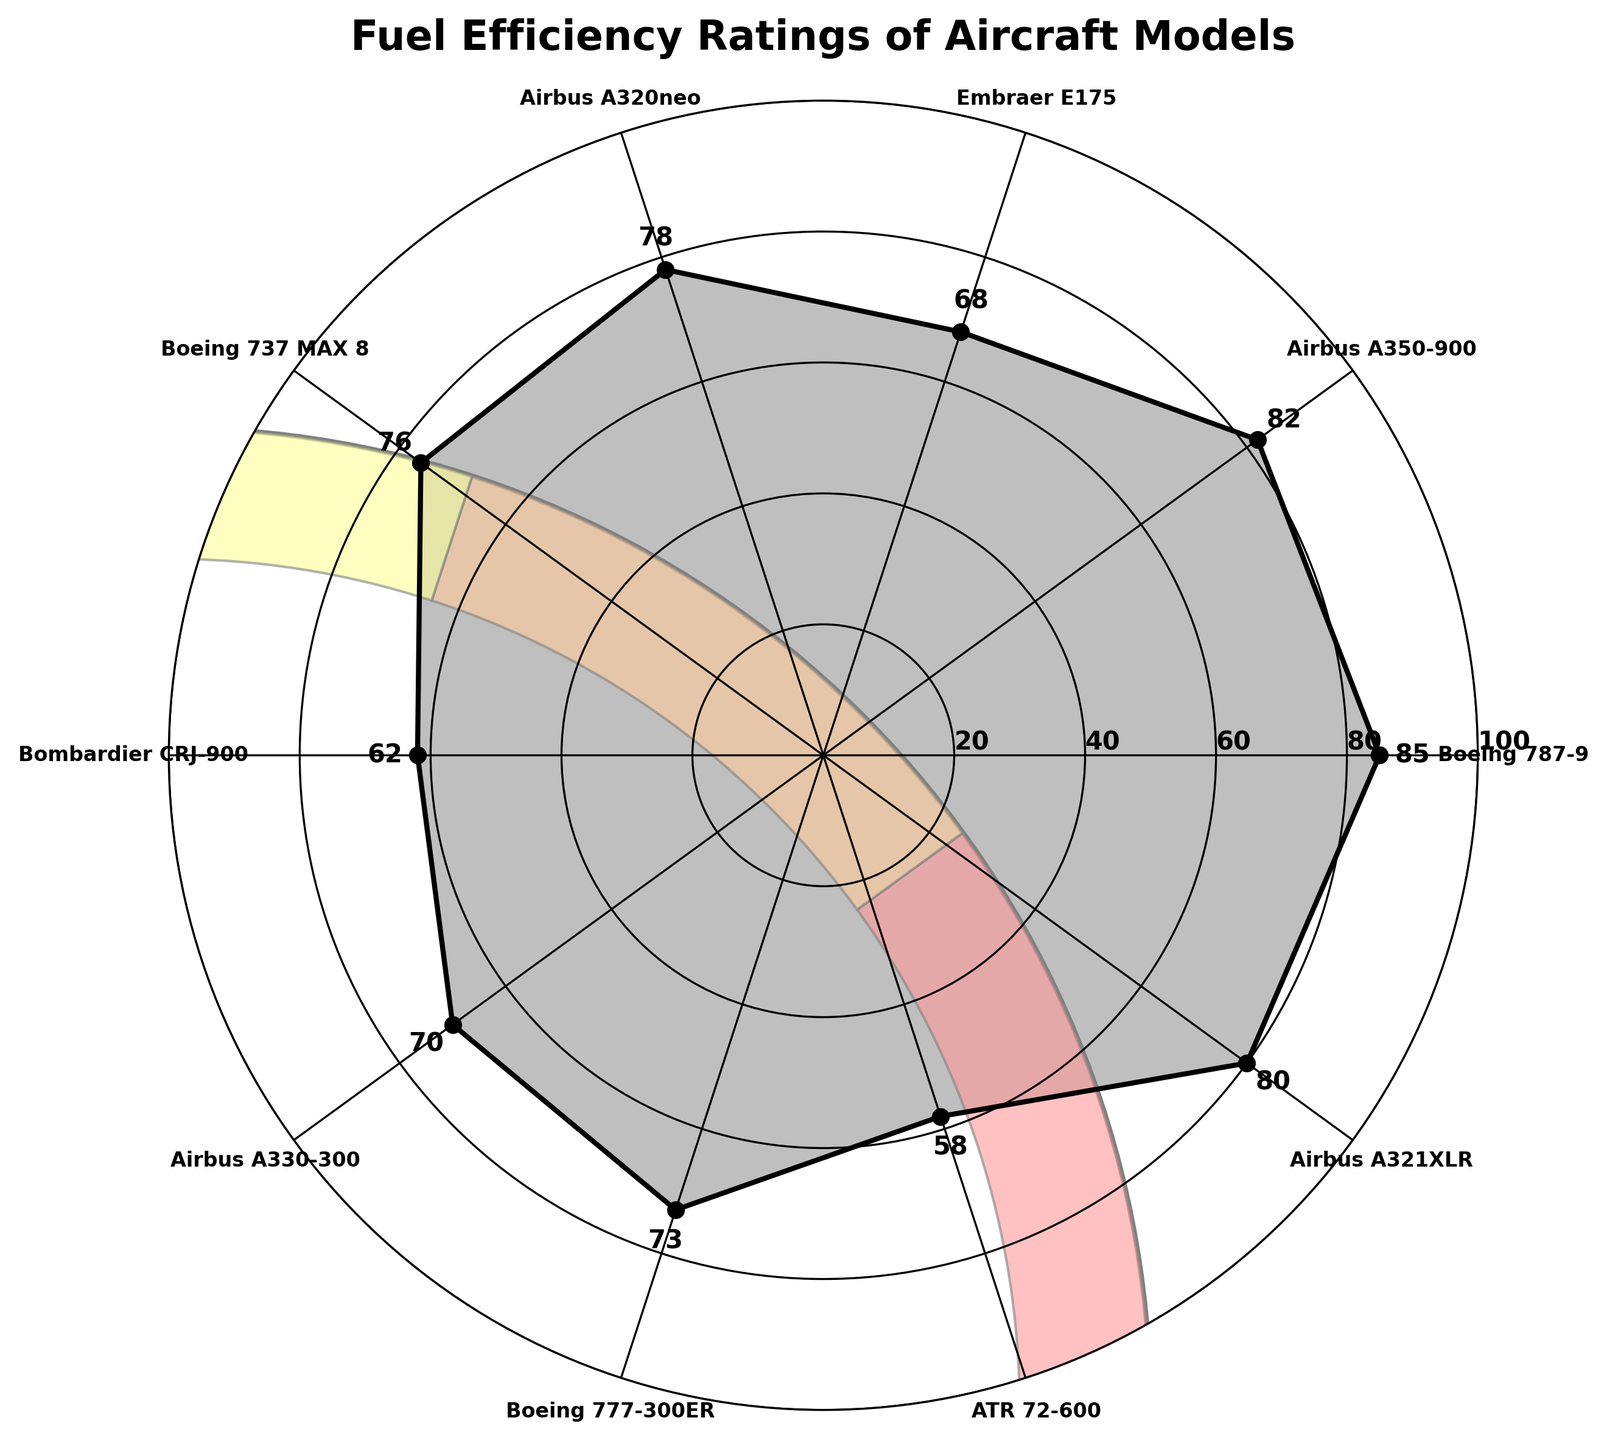What is the title of the chart? The title is displayed at the top of the figure and reads 'Fuel Efficiency Ratings of Aircraft Models'.
Answer: 'Fuel Efficiency Ratings of Aircraft Models' How many aircraft models are represented in the gauge chart? The chart has markers at several points around the circle, each labeled with the name of an aircraft model. Counting these labels provides the total number.
Answer: 10 Which aircraft model has the highest fuel efficiency rating? Look at the data series plotted along the gauge, which shows values up to the highest point. The aircraft model with the highest rating is identified by its label near this point.
Answer: Boeing 787-9 Which aircraft model has the lowest fuel efficiency rating? Look for the lowest point on the gauge chart and identify the corresponding aircraft model labeled near this point.
Answer: ATR 72-600 What is the fuel efficiency rating of the Airbus A350-900? Identify the label for 'Airbus A350-900' on the gauge chart, and then observe the fuel efficiency rating number associated with this label.
Answer: 82 What's the average fuel efficiency rating of all the aircraft models in the chart? Sum all the fuel efficiency ratings (85, 82, 68, 78, 76, 62, 70, 73, 58, 80) and then divide by the number of models (10). Calculation: (85 + 82 + 68 + 78 + 76 + 62 + 70 + 73 + 58 + 80) / 10 = 73.2
Answer: 73.2 What is the difference in fuel efficiency ratings between the Boeing 787-9 and the Bombardier CRJ-900? Find the fuel efficiency ratings for both models: Boeing 787-9 (85) and Bombardier CRJ-900 (62), then subtract the lower rating from the higher one. Calculation: 85 - 62 = 23
Answer: 23 How does the fuel efficiency rating of the Airbus A320neo compare to the Boeing 737 MAX 8? Look at the ratings for each model: Airbus A320neo (78) and Boeing 737 MAX 8 (76), and compare them. The Airbus A320neo has a higher rating.
Answer: Airbus A320neo has a higher rating Arrange the aircraft models with a fuel efficiency rating above 80 in ascending order. Identify models with ratings above 80: Boeing 787-9 (85), Airbus A350-900 (82), and Airbus A321XLR (80). Arrange: Airbus A321XLR (80), Airbus A350-900 (82), Boeing 787-9 (85).
Answer: Airbus A321XLR, Airbus A350-900, Boeing 787-9 What visual enhancements are included in the gauge chart to help interpret the data? The chart includes color bands, text labels with ratings above each point, and a filled polygon area. The bands represent different ranges of ratings, the text labels provide precise ratings for each model, and the filled area visually connects the data points.
Answer: Color bands, text labels, filled polygon area 